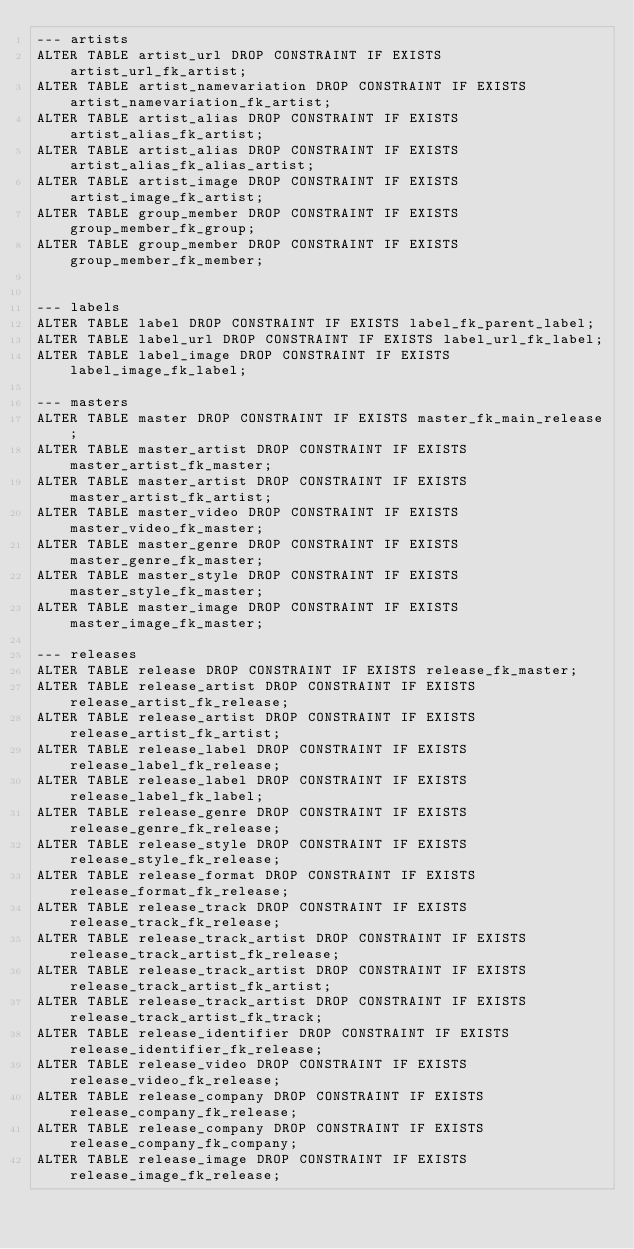Convert code to text. <code><loc_0><loc_0><loc_500><loc_500><_SQL_>--- artists
ALTER TABLE artist_url DROP CONSTRAINT IF EXISTS artist_url_fk_artist;
ALTER TABLE artist_namevariation DROP CONSTRAINT IF EXISTS artist_namevariation_fk_artist;
ALTER TABLE artist_alias DROP CONSTRAINT IF EXISTS artist_alias_fk_artist;
ALTER TABLE artist_alias DROP CONSTRAINT IF EXISTS artist_alias_fk_alias_artist;
ALTER TABLE artist_image DROP CONSTRAINT IF EXISTS artist_image_fk_artist;
ALTER TABLE group_member DROP CONSTRAINT IF EXISTS group_member_fk_group;
ALTER TABLE group_member DROP CONSTRAINT IF EXISTS group_member_fk_member;


--- labels
ALTER TABLE label DROP CONSTRAINT IF EXISTS label_fk_parent_label;
ALTER TABLE label_url DROP CONSTRAINT IF EXISTS label_url_fk_label;
ALTER TABLE label_image DROP CONSTRAINT IF EXISTS label_image_fk_label;

--- masters
ALTER TABLE master DROP CONSTRAINT IF EXISTS master_fk_main_release;
ALTER TABLE master_artist DROP CONSTRAINT IF EXISTS master_artist_fk_master;
ALTER TABLE master_artist DROP CONSTRAINT IF EXISTS master_artist_fk_artist;
ALTER TABLE master_video DROP CONSTRAINT IF EXISTS master_video_fk_master;
ALTER TABLE master_genre DROP CONSTRAINT IF EXISTS master_genre_fk_master;
ALTER TABLE master_style DROP CONSTRAINT IF EXISTS master_style_fk_master;
ALTER TABLE master_image DROP CONSTRAINT IF EXISTS master_image_fk_master;

--- releases
ALTER TABLE release DROP CONSTRAINT IF EXISTS release_fk_master;
ALTER TABLE release_artist DROP CONSTRAINT IF EXISTS release_artist_fk_release;
ALTER TABLE release_artist DROP CONSTRAINT IF EXISTS release_artist_fk_artist;
ALTER TABLE release_label DROP CONSTRAINT IF EXISTS release_label_fk_release;
ALTER TABLE release_label DROP CONSTRAINT IF EXISTS release_label_fk_label;
ALTER TABLE release_genre DROP CONSTRAINT IF EXISTS release_genre_fk_release;
ALTER TABLE release_style DROP CONSTRAINT IF EXISTS release_style_fk_release;
ALTER TABLE release_format DROP CONSTRAINT IF EXISTS release_format_fk_release;
ALTER TABLE release_track DROP CONSTRAINT IF EXISTS release_track_fk_release;
ALTER TABLE release_track_artist DROP CONSTRAINT IF EXISTS release_track_artist_fk_release;
ALTER TABLE release_track_artist DROP CONSTRAINT IF EXISTS release_track_artist_fk_artist;
ALTER TABLE release_track_artist DROP CONSTRAINT IF EXISTS release_track_artist_fk_track;
ALTER TABLE release_identifier DROP CONSTRAINT IF EXISTS release_identifier_fk_release;
ALTER TABLE release_video DROP CONSTRAINT IF EXISTS release_video_fk_release;
ALTER TABLE release_company DROP CONSTRAINT IF EXISTS release_company_fk_release;
ALTER TABLE release_company DROP CONSTRAINT IF EXISTS release_company_fk_company;
ALTER TABLE release_image DROP CONSTRAINT IF EXISTS release_image_fk_release;
</code> 